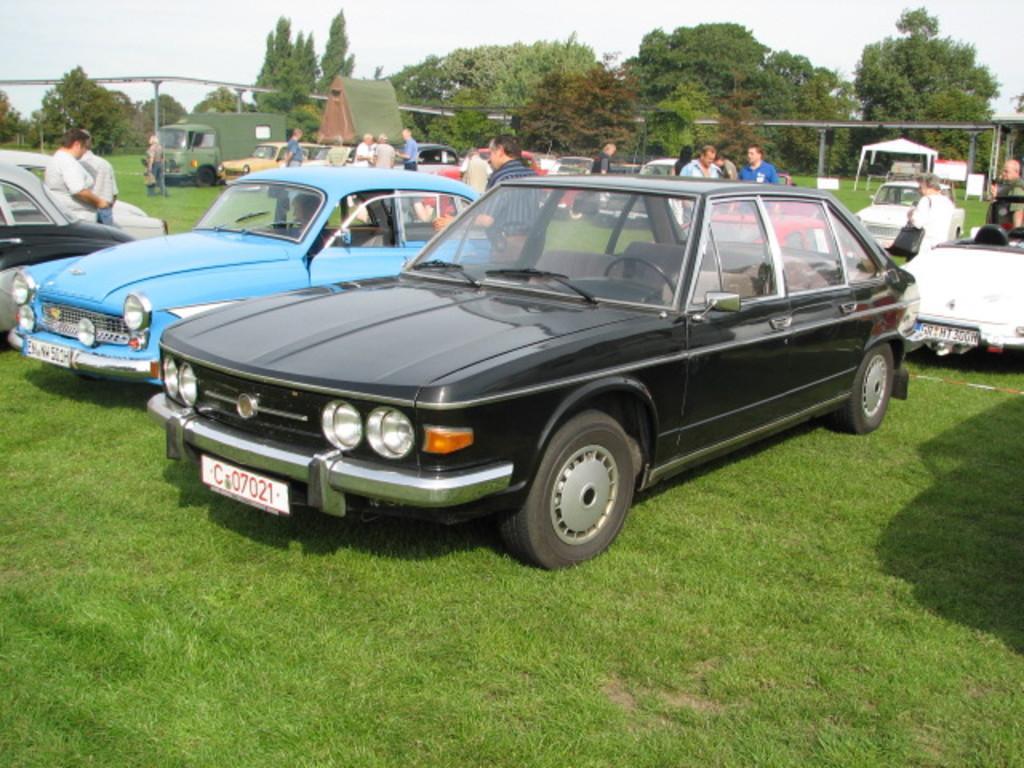Could you give a brief overview of what you see in this image? In this picture there are cars and there are group of people standing behind the cars. On the right side of the image there is a tent. At the back there are trees. At the top there is sky. At the bottom there is grass. 